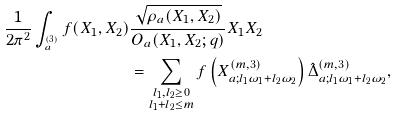Convert formula to latex. <formula><loc_0><loc_0><loc_500><loc_500>\frac { 1 } { 2 \pi ^ { 2 } } \int _ { ^ { ( 3 ) } _ { a } } f ( X _ { 1 } , X _ { 2 } ) & \frac { \sqrt { \rho _ { a } ( X _ { 1 } , X _ { 2 } ) } } { O _ { a } ( X _ { 1 } , X _ { 2 } ; q ) } X _ { 1 } X _ { 2 } \\ & = \sum _ { \substack { l _ { 1 } , l _ { 2 } \geq 0 \\ l _ { 1 } + l _ { 2 } \leq m } } f \left ( X ^ { ( m , 3 ) } _ { a ; l _ { 1 } \omega _ { 1 } + l _ { 2 } \omega _ { 2 } } \right ) \hat { \Delta } ^ { ( m , 3 ) } _ { a ; l _ { 1 } \omega _ { 1 } + l _ { 2 } \omega _ { 2 } } ,</formula> 